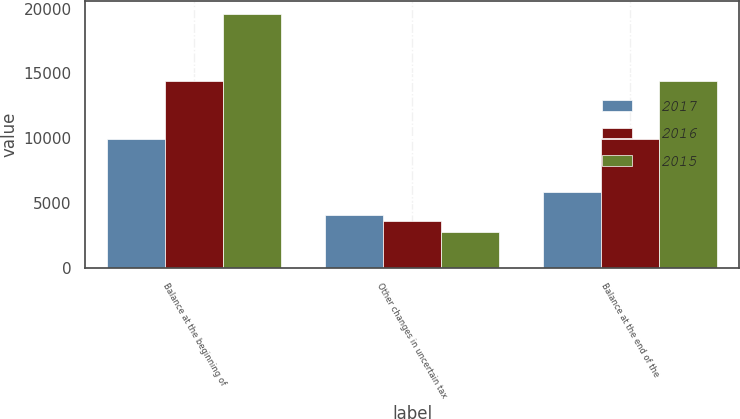<chart> <loc_0><loc_0><loc_500><loc_500><stacked_bar_chart><ecel><fcel>Balance at the beginning of<fcel>Other changes in uncertain tax<fcel>Balance at the end of the<nl><fcel>2017<fcel>9964<fcel>4121<fcel>5843<nl><fcel>2016<fcel>14450<fcel>3658<fcel>9964<nl><fcel>2015<fcel>19596<fcel>2741<fcel>14450<nl></chart> 